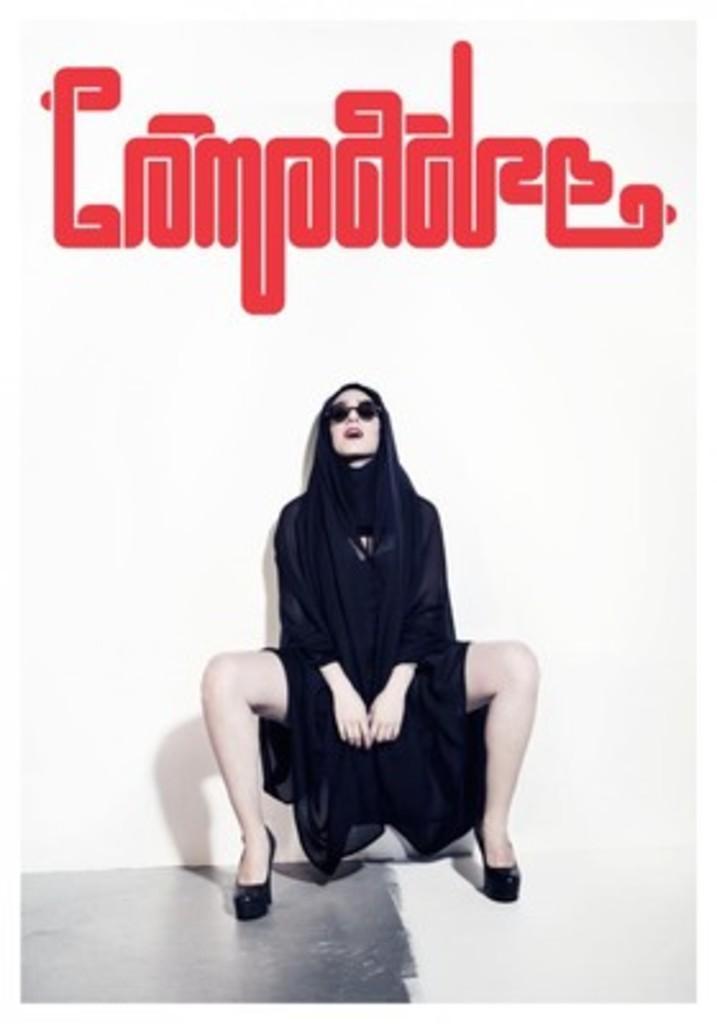In one or two sentences, can you explain what this image depicts? In the center of the picture there is a woman in black dress. At the top there is some text. In this picture behind the woman there is a wall painted white. 